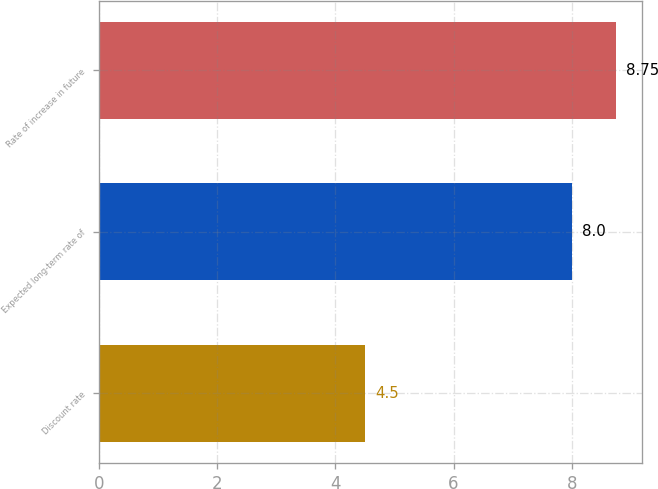Convert chart to OTSL. <chart><loc_0><loc_0><loc_500><loc_500><bar_chart><fcel>Discount rate<fcel>Expected long-term rate of<fcel>Rate of increase in future<nl><fcel>4.5<fcel>8<fcel>8.75<nl></chart> 